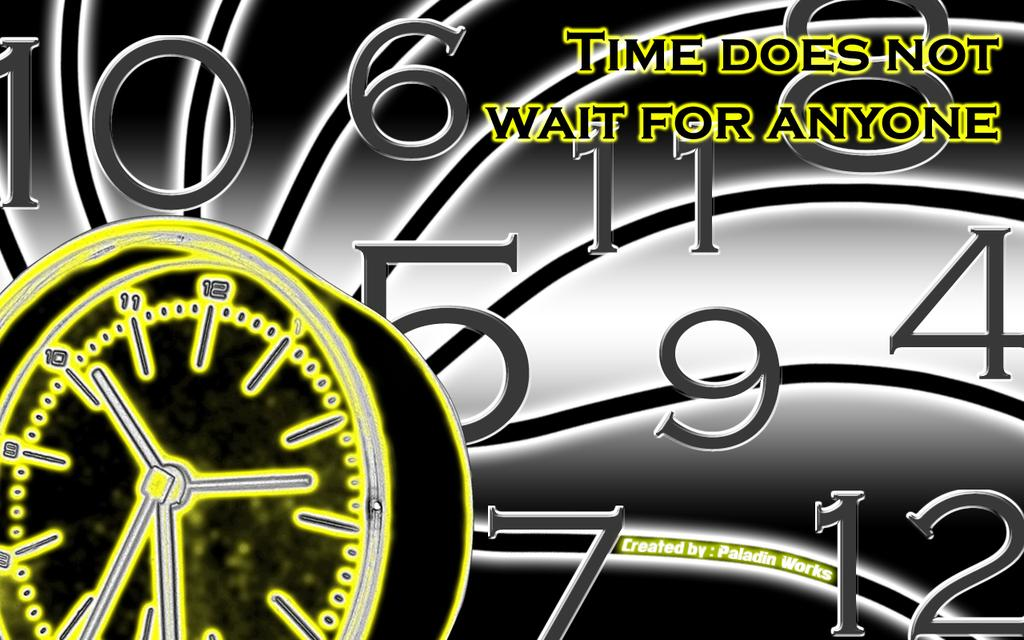What is the main subject of the poster in the image? The main subject of the poster in the image is an animated picture of a watch. What is the message conveyed by the poster? The phrase "Time doesn't wait for anyone" is present on the poster, conveying the message that time is valuable and cannot be wasted. What other elements can be seen on the poster? Numbers are visible in the image, likely referring to the time displayed on the watch. What type of island can be seen in the image? There is no island present in the image; it features a poster with an animated picture of a watch. Is it raining in the image? There is no indication of rain in the image; it shows a poster with an animated picture of a watch. 